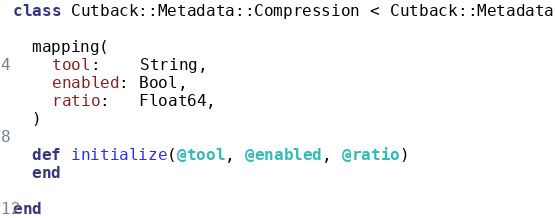<code> <loc_0><loc_0><loc_500><loc_500><_Crystal_>class Cutback::Metadata::Compression < Cutback::Metadata

  mapping(
    tool:    String,
    enabled: Bool,
    ratio:   Float64,
  )

  def initialize(@tool, @enabled, @ratio)
  end

end

</code> 